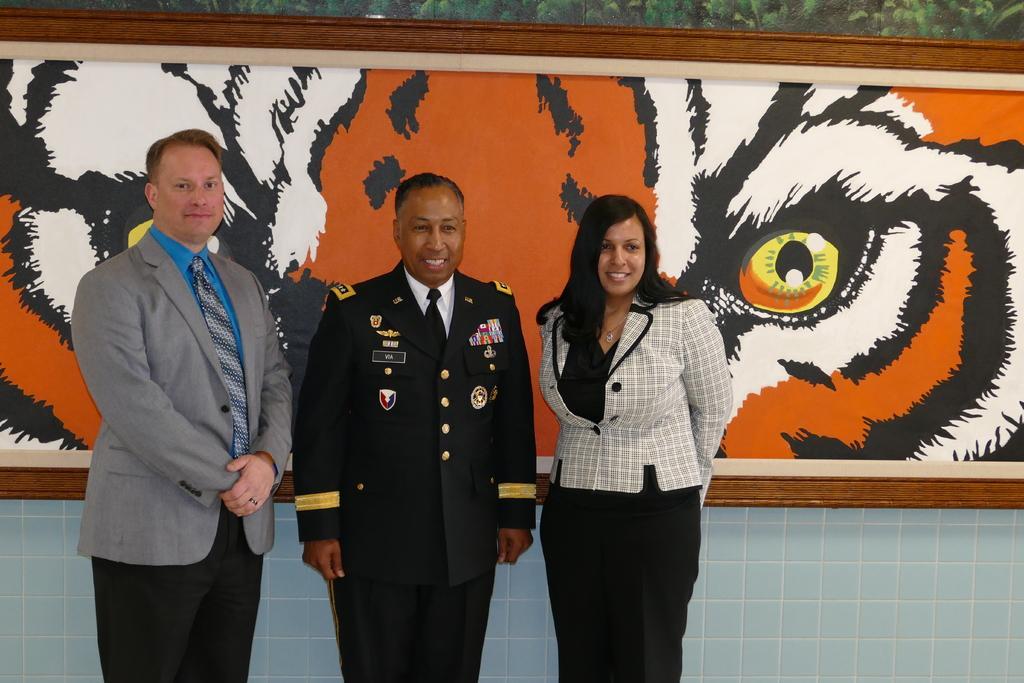Could you give a brief overview of what you see in this image? In the middle of the image I can few people are standing. In the background, I can see the frame. 